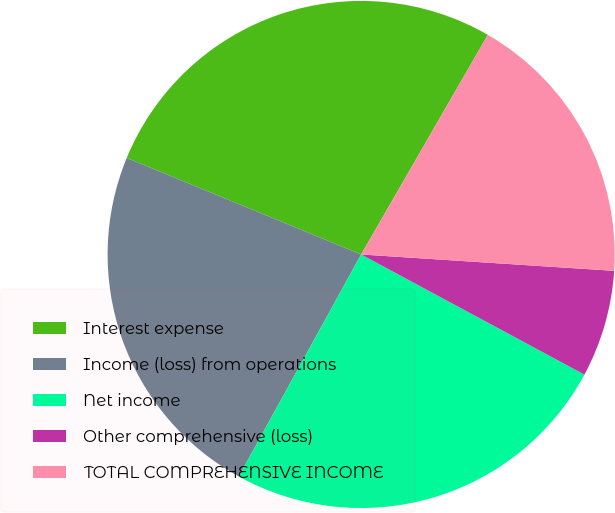Convert chart. <chart><loc_0><loc_0><loc_500><loc_500><pie_chart><fcel>Interest expense<fcel>Income (loss) from operations<fcel>Net income<fcel>Other comprehensive (loss)<fcel>TOTAL COMPREHENSIVE INCOME<nl><fcel>27.11%<fcel>23.2%<fcel>25.16%<fcel>6.83%<fcel>17.7%<nl></chart> 